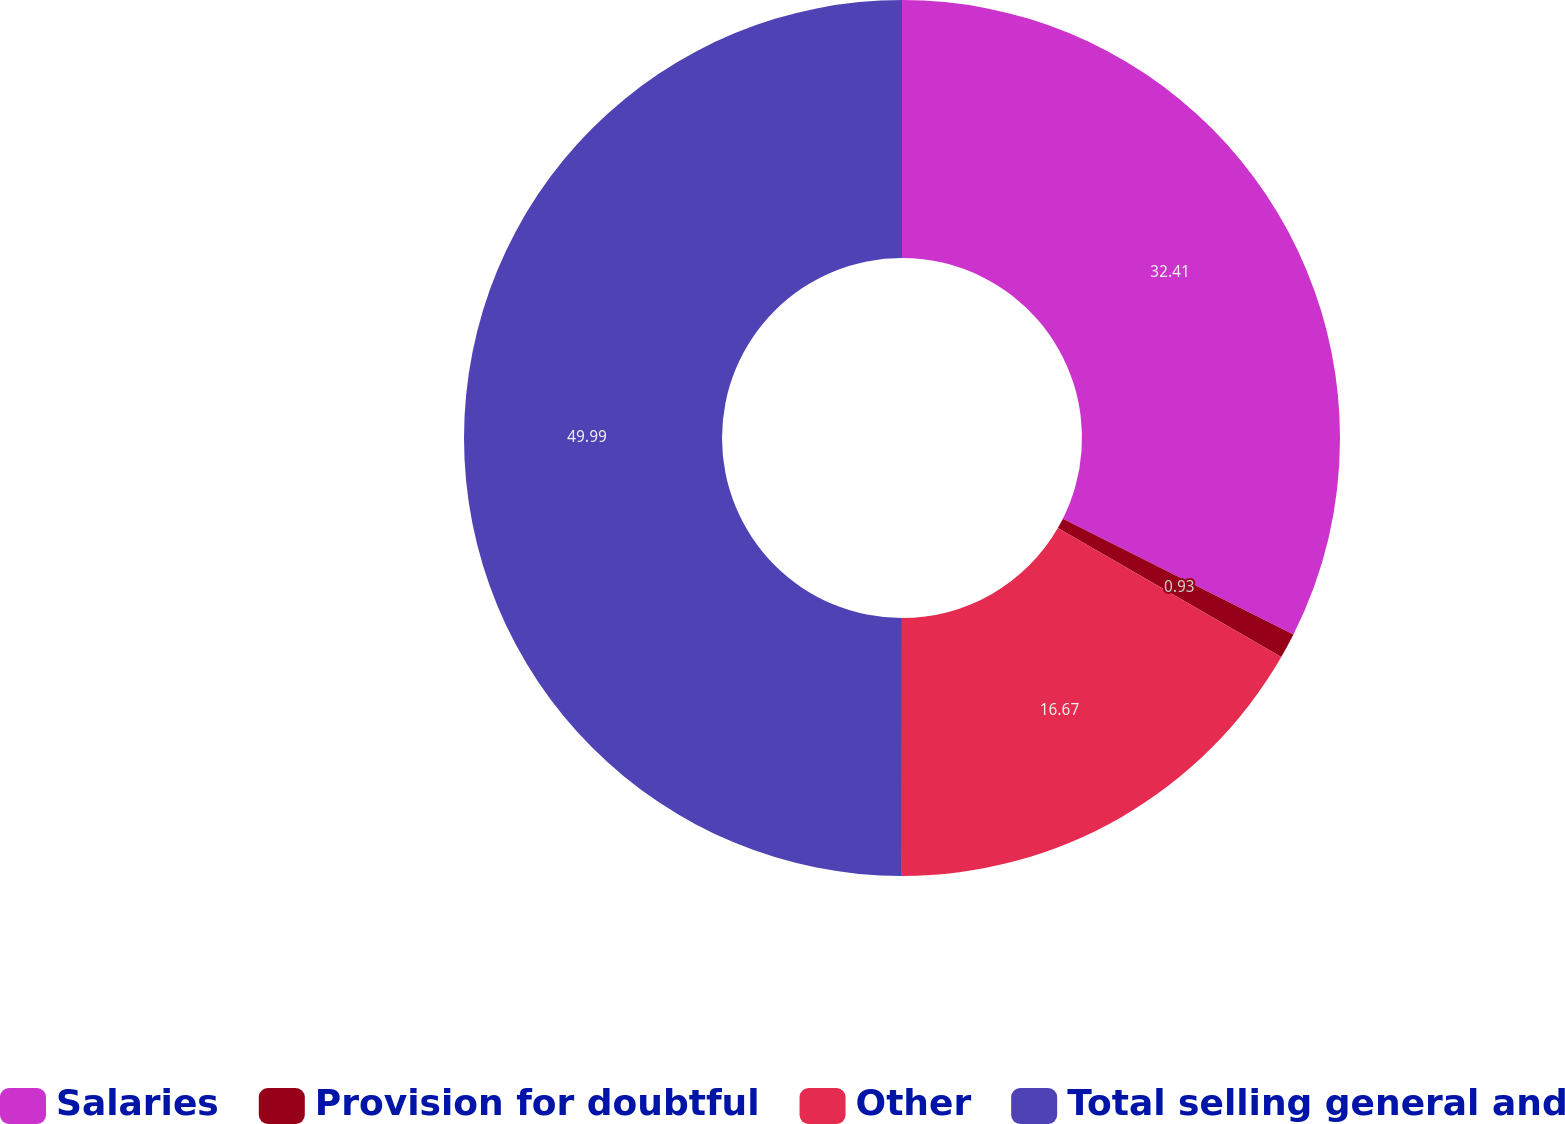Convert chart to OTSL. <chart><loc_0><loc_0><loc_500><loc_500><pie_chart><fcel>Salaries<fcel>Provision for doubtful<fcel>Other<fcel>Total selling general and<nl><fcel>32.41%<fcel>0.93%<fcel>16.67%<fcel>50.0%<nl></chart> 